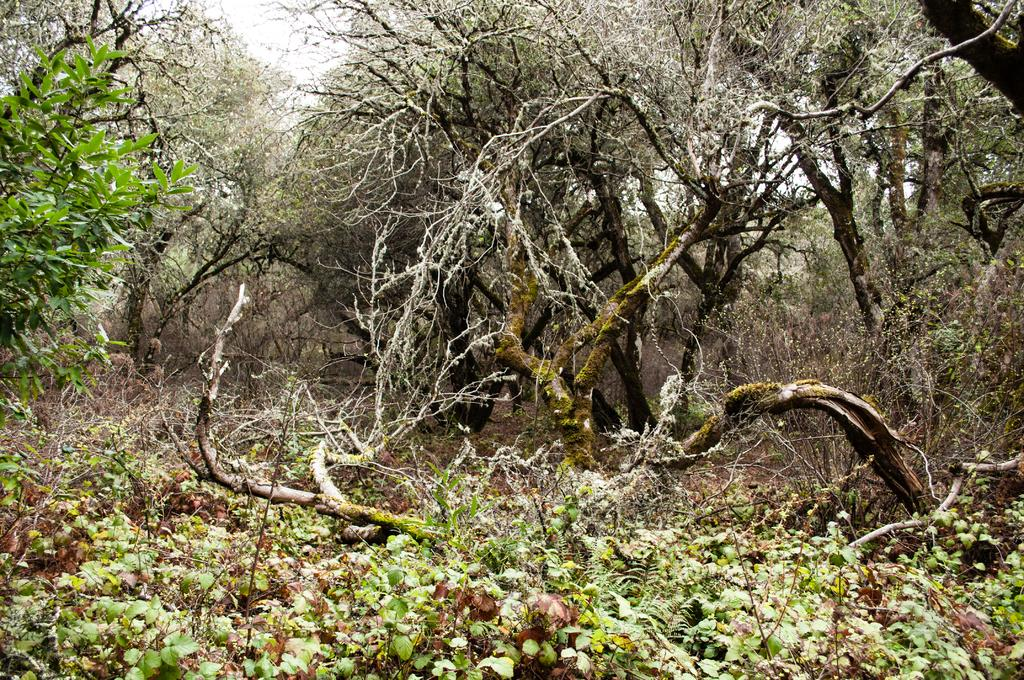What type of vegetation is present at the bottom of the image? There are plants at the bottom of the image. What can be seen in the background of the image? There are trees in the background of the image. What color is the elbow of the tree in the image? There is no mention of an elbow in the image, as trees do not have elbows. 